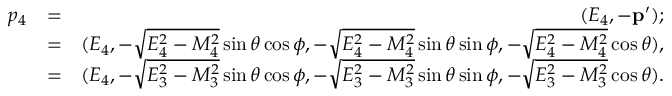<formula> <loc_0><loc_0><loc_500><loc_500>\begin{array} { r l r } { p _ { 4 } } & { = } & { ( E _ { 4 } , - p ^ { \prime } ) ; } \\ & { = } & { ( E _ { 4 } , - \sqrt { E _ { 4 } ^ { 2 } - M _ { 4 } ^ { 2 } } \sin \theta \cos \phi , - \sqrt { E _ { 4 } ^ { 2 } - M _ { 4 } ^ { 2 } } \sin \theta \sin \phi , - \sqrt { E _ { 4 } ^ { 2 } - M _ { 4 } ^ { 2 } } \cos \theta ) , } \\ & { = } & { ( E _ { 4 } , - \sqrt { E _ { 3 } ^ { 2 } - M _ { 3 } ^ { 2 } } \sin \theta \cos \phi , - \sqrt { E _ { 3 } ^ { 2 } - M _ { 3 } ^ { 2 } } \sin \theta \sin \phi , - \sqrt { E _ { 3 } ^ { 2 } - M _ { 3 } ^ { 2 } } \cos \theta ) . } \end{array}</formula> 